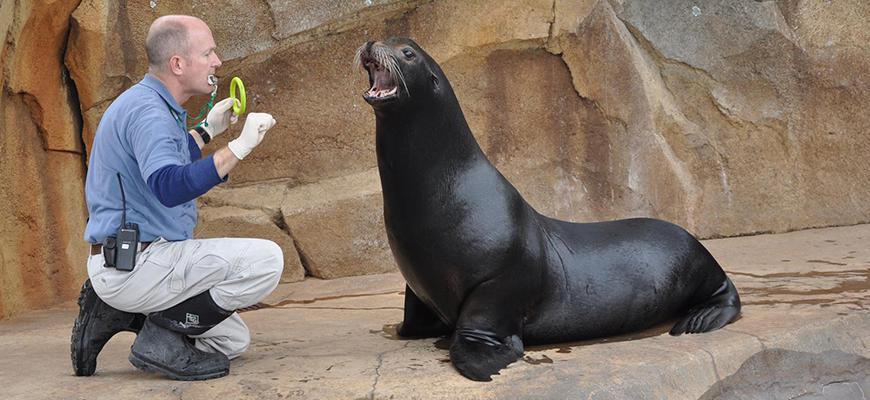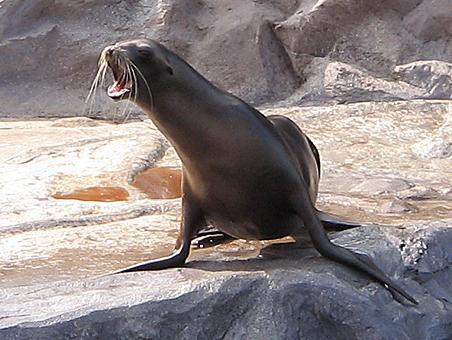The first image is the image on the left, the second image is the image on the right. Considering the images on both sides, is "A man is interacting with one of the seals." valid? Answer yes or no. Yes. The first image is the image on the left, the second image is the image on the right. Given the left and right images, does the statement "There is one trainer working with a seal in the image on the left." hold true? Answer yes or no. Yes. 